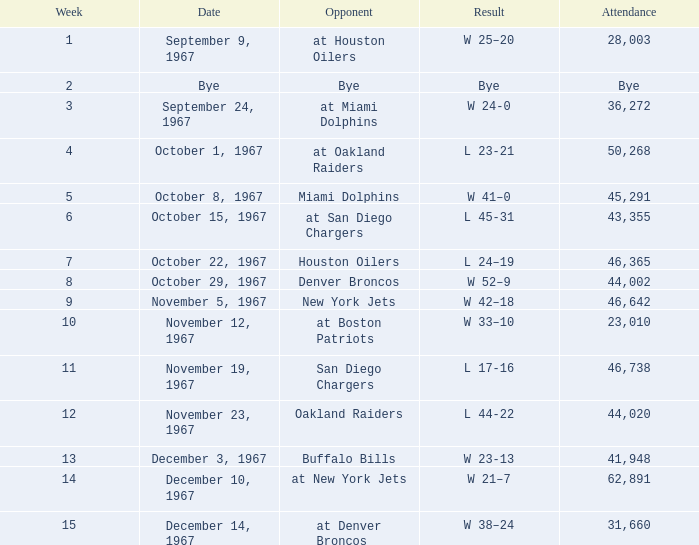Who was the opponent after week 9 with an attendance of 44,020? Oakland Raiders. 